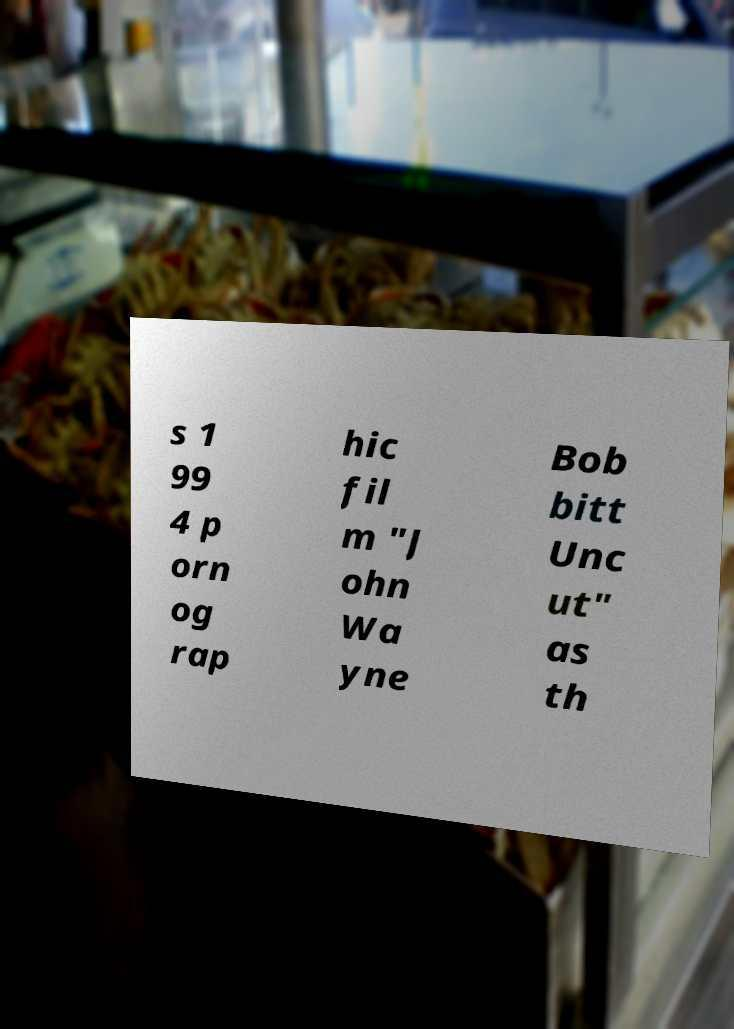Could you assist in decoding the text presented in this image and type it out clearly? s 1 99 4 p orn og rap hic fil m "J ohn Wa yne Bob bitt Unc ut" as th 